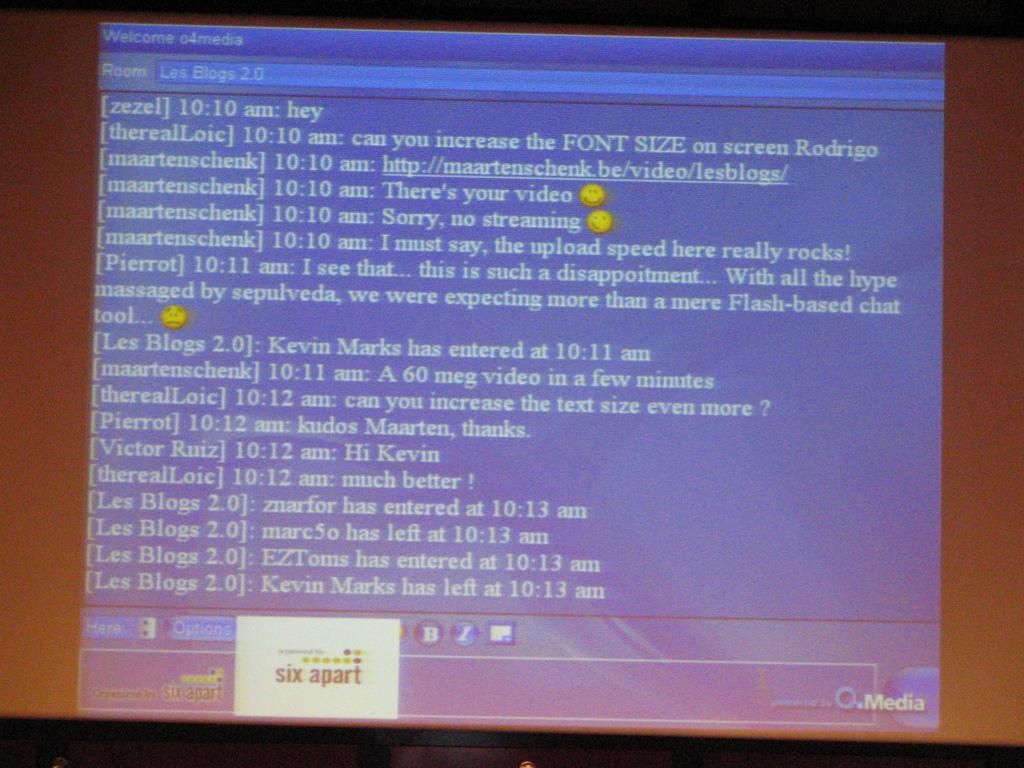<image>
Share a concise interpretation of the image provided. A chat is seen on a screen, and user maartenschenk sent two emojis. 